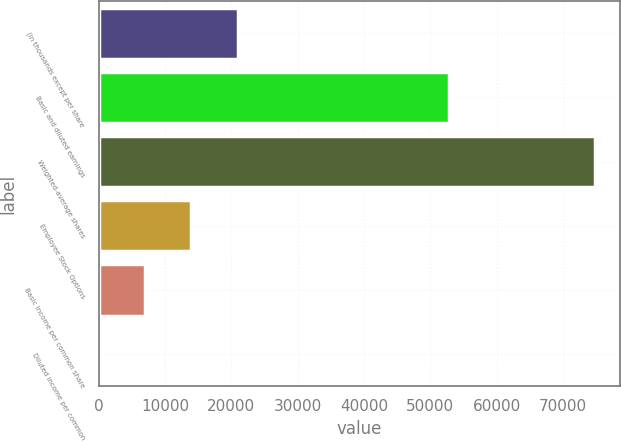Convert chart. <chart><loc_0><loc_0><loc_500><loc_500><bar_chart><fcel>(in thousands except per share<fcel>Basic and diluted earnings<fcel>Weighted-average shares<fcel>Employee Stock Options<fcel>Basic income per common share<fcel>Diluted income per common<nl><fcel>20932.1<fcel>52773<fcel>74875.1<fcel>13955<fcel>6977.88<fcel>0.76<nl></chart> 